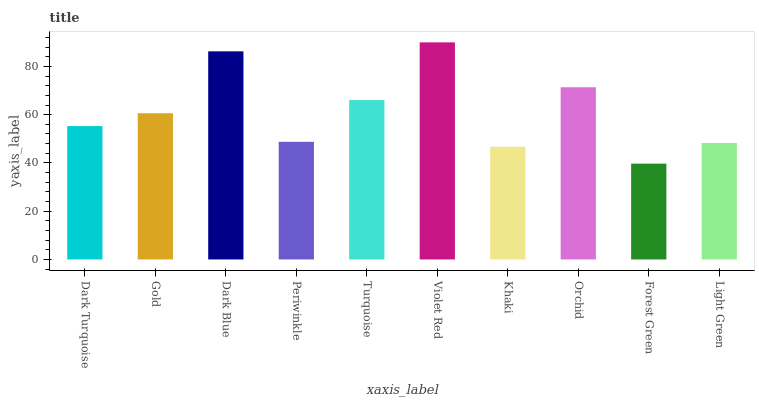Is Forest Green the minimum?
Answer yes or no. Yes. Is Violet Red the maximum?
Answer yes or no. Yes. Is Gold the minimum?
Answer yes or no. No. Is Gold the maximum?
Answer yes or no. No. Is Gold greater than Dark Turquoise?
Answer yes or no. Yes. Is Dark Turquoise less than Gold?
Answer yes or no. Yes. Is Dark Turquoise greater than Gold?
Answer yes or no. No. Is Gold less than Dark Turquoise?
Answer yes or no. No. Is Gold the high median?
Answer yes or no. Yes. Is Dark Turquoise the low median?
Answer yes or no. Yes. Is Dark Turquoise the high median?
Answer yes or no. No. Is Periwinkle the low median?
Answer yes or no. No. 